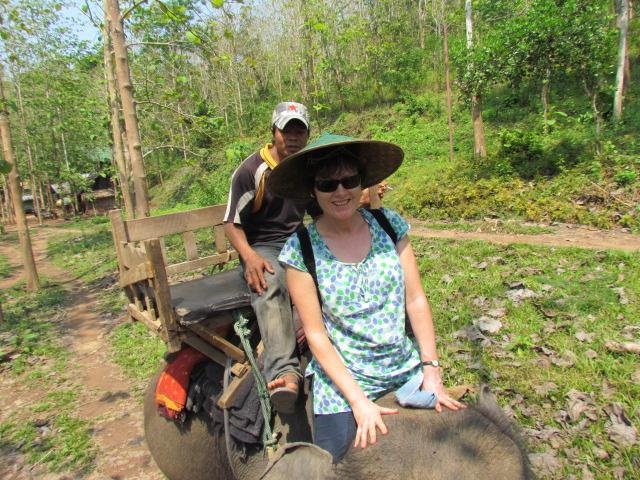Who is guiding the elephant? Please explain your reasoning. man. The guy behind the woman is giving the lady a ride on the elephant. 